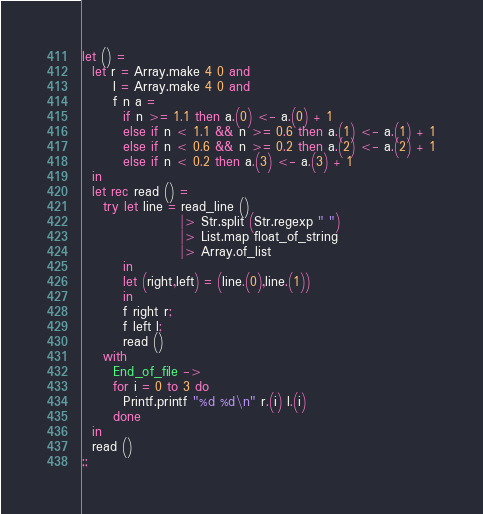<code> <loc_0><loc_0><loc_500><loc_500><_OCaml_>let () =
  let r = Array.make 4 0 and
      l = Array.make 4 0 and
      f n a =
        if n >= 1.1 then a.(0) <- a.(0) + 1
        else if n < 1.1 && n >= 0.6 then a.(1) <- a.(1) + 1
        else if n < 0.6 && n >= 0.2 then a.(2) <- a.(2) + 1
        else if n < 0.2 then a.(3) <- a.(3) + 1
  in
  let rec read () =
    try let line = read_line ()
                   |> Str.split (Str.regexp " ")
                   |> List.map float_of_string
                   |> Array.of_list
        in
        let (right,left) = (line.(0),line.(1))
        in
        f right r;
        f left l;
        read ()
    with
      End_of_file ->
      for i = 0 to 3 do
        Printf.printf "%d %d\n" r.(i) l.(i)
      done
  in
  read ()
;;</code> 